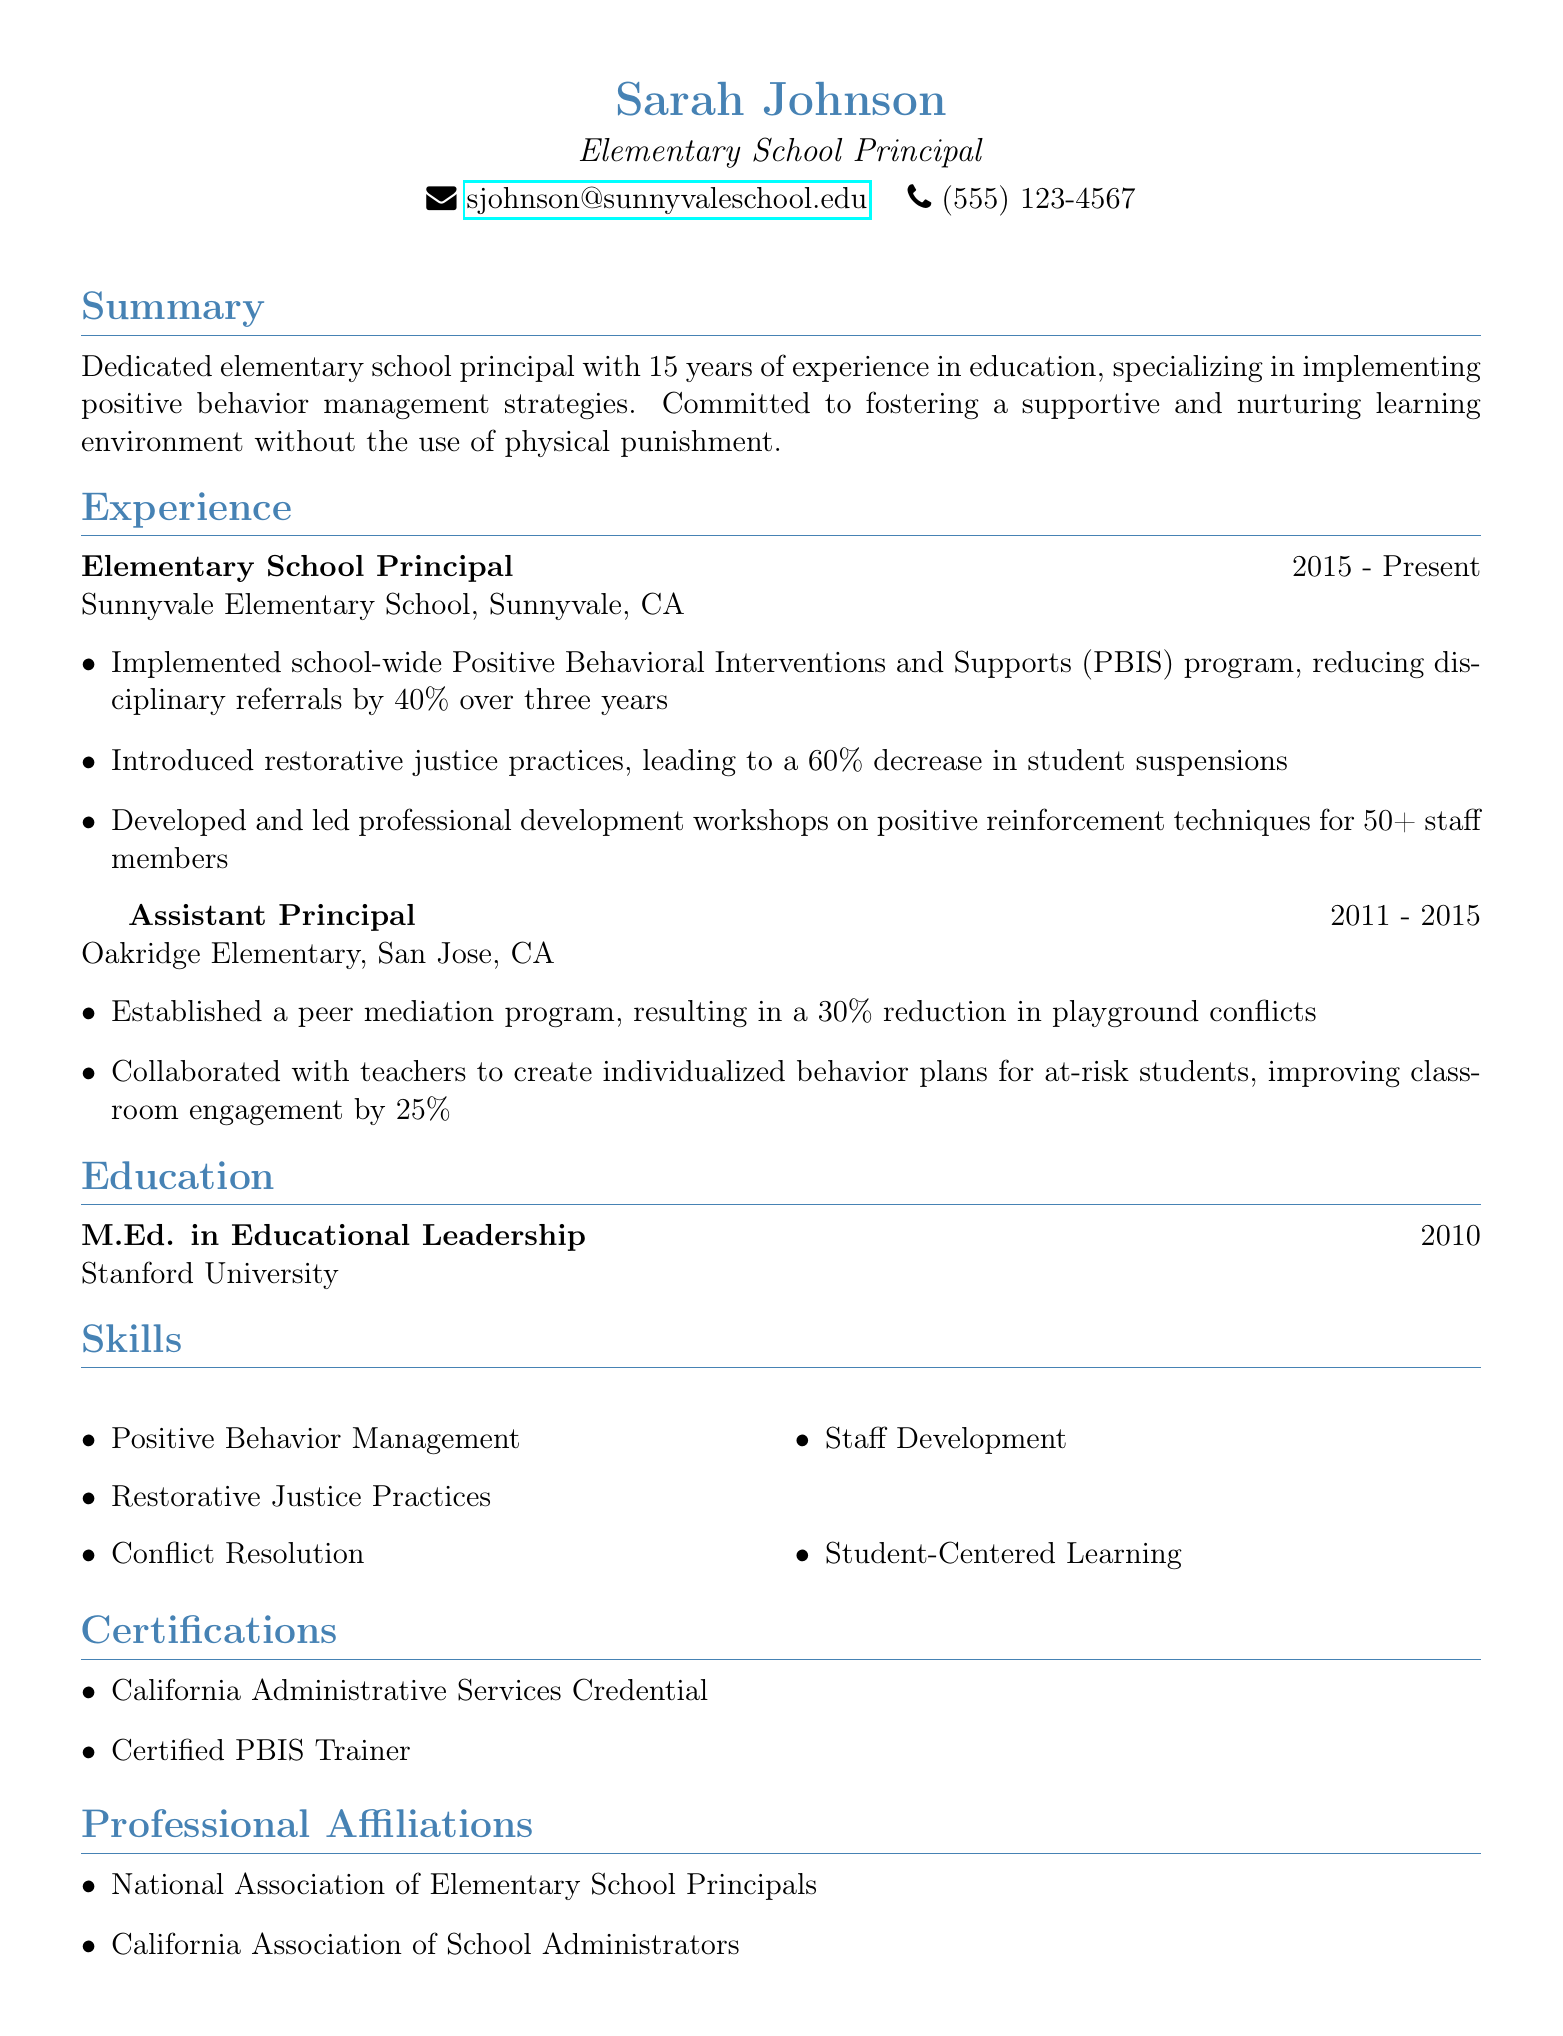What is the name of the principal? The name of the principal is provided at the top of the document.
Answer: Sarah Johnson What degree does Sarah Johnson hold? The degree is listed under the education section of the document.
Answer: M.Ed. in Educational Leadership What organization did Sarah Johnson serve as principal? The organization name is stated in the experience section.
Answer: Sunnyvale Elementary School In which year did Sarah Johnson start working at Sunnyvale Elementary School? The start year is mentioned in the experience section.
Answer: 2015 How much did disciplinary referrals decrease by after implementing PBIS? The specific percentage decrease is detailed in the achievements under experience.
Answer: 40% What type of practices did Sarah introduce to reduce suspensions? The type of practices is mentioned in relation to her achievements.
Answer: Restorative justice practices How many staff members attended the professional development workshops? The number of staff attendees is specified in the achievements section.
Answer: 50+ What is one skill listed in Sarah Johnson's resume? Skills are outlined in the skills section of the document.
Answer: Positive Behavior Management What certification does Sarah Johnson have related to PBIS? The certification is specifically mentioned under certifications.
Answer: Certified PBIS Trainer 